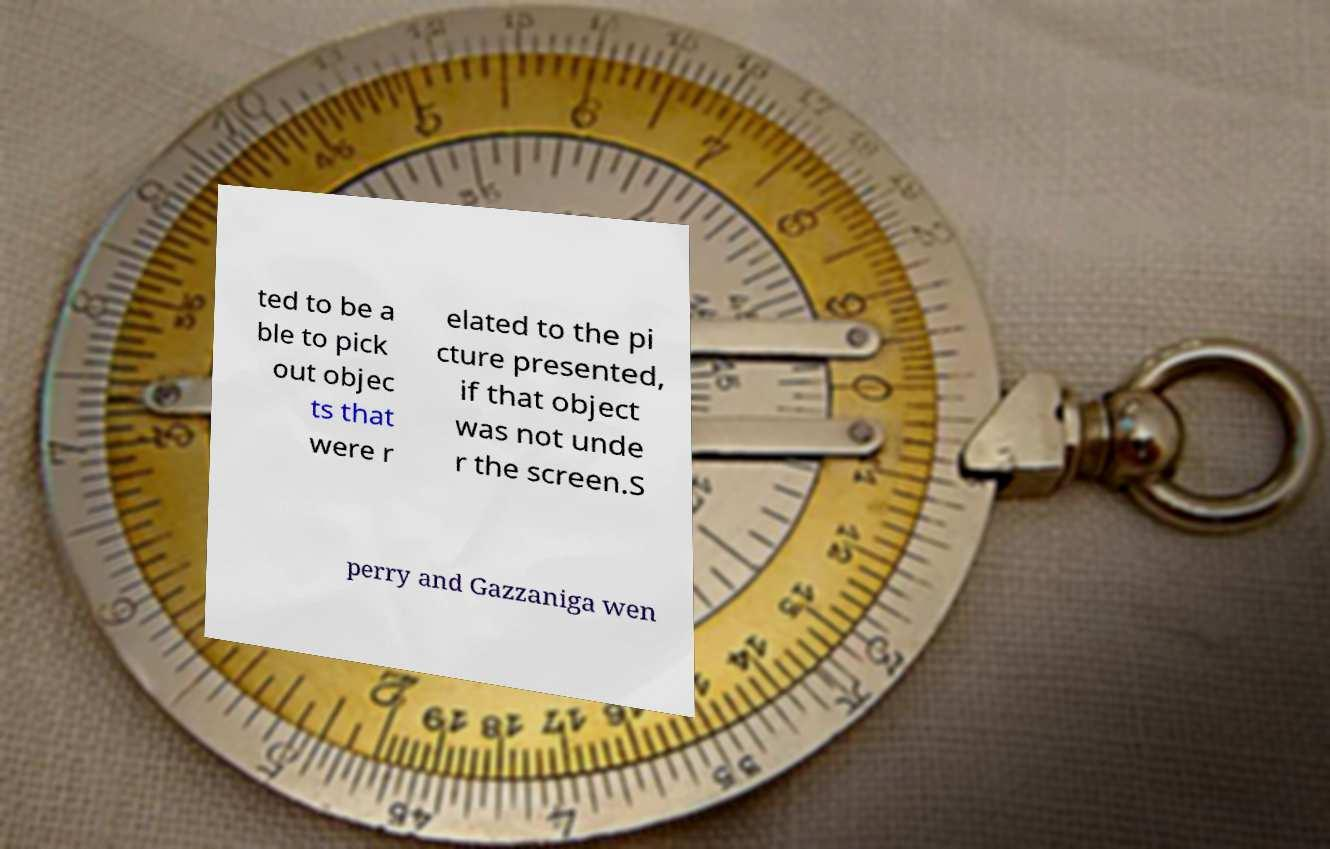What messages or text are displayed in this image? I need them in a readable, typed format. ted to be a ble to pick out objec ts that were r elated to the pi cture presented, if that object was not unde r the screen.S perry and Gazzaniga wen 